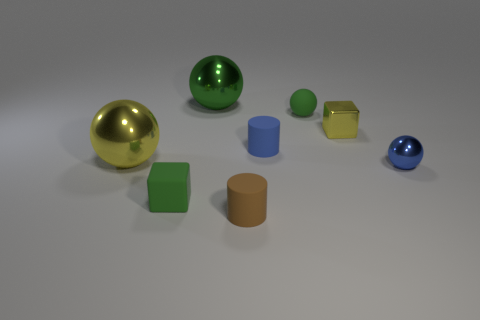Add 1 blue spheres. How many objects exist? 9 Subtract all blocks. How many objects are left? 6 Subtract 0 cyan cylinders. How many objects are left? 8 Subtract all large spheres. Subtract all large blue cylinders. How many objects are left? 6 Add 4 matte objects. How many matte objects are left? 8 Add 2 tiny metallic blocks. How many tiny metallic blocks exist? 3 